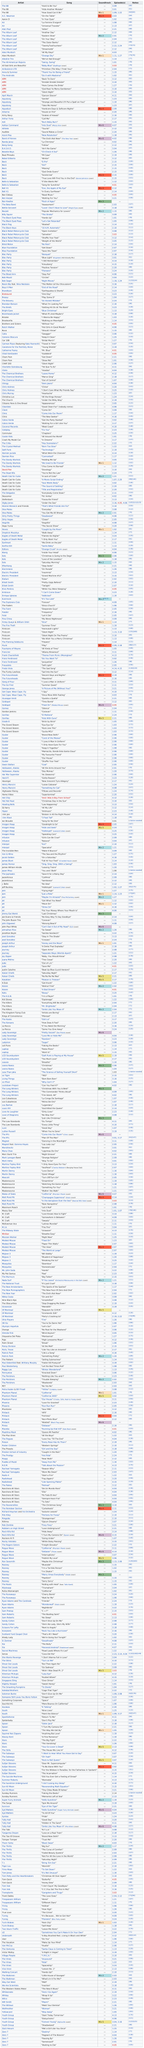Specify some key components in this picture. There are 27 episodes that have received a rating below 2.00. The track 'Du Temps' by The Low Standards is 4 minutes and 11 seconds in length. There were 6 consecutive songs by the album leaf. The songs "girl" and "el pro" were performed by the artist known as Beck. The album leaf was responsible for 6 songs in total. 